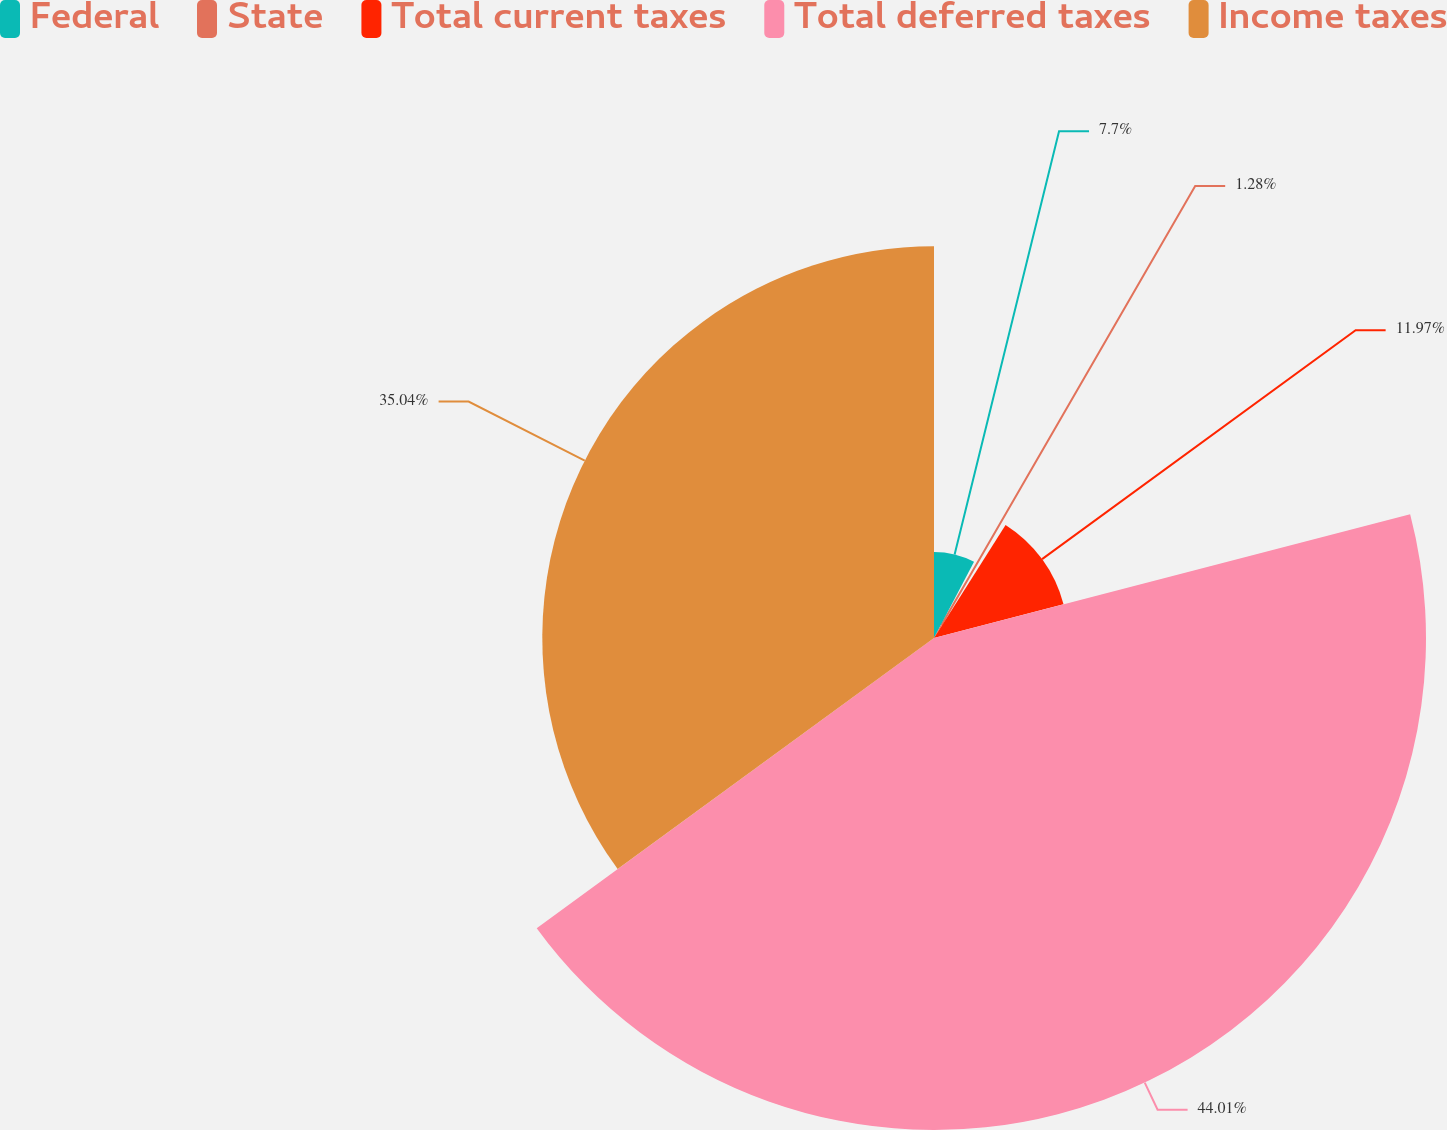Convert chart. <chart><loc_0><loc_0><loc_500><loc_500><pie_chart><fcel>Federal<fcel>State<fcel>Total current taxes<fcel>Total deferred taxes<fcel>Income taxes<nl><fcel>7.7%<fcel>1.28%<fcel>11.97%<fcel>44.01%<fcel>35.04%<nl></chart> 